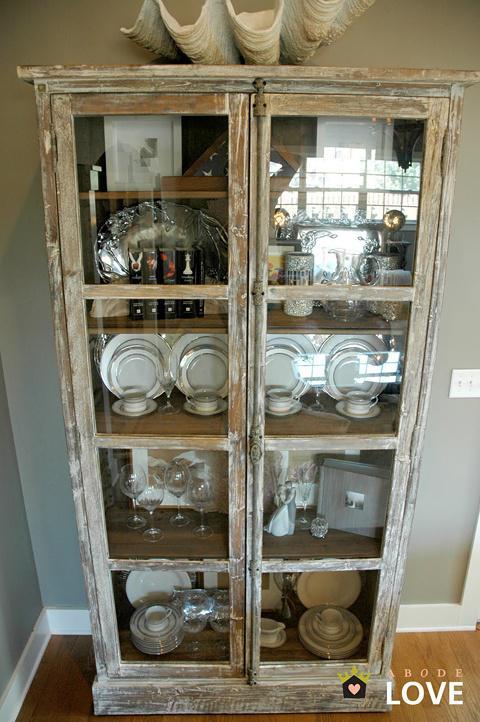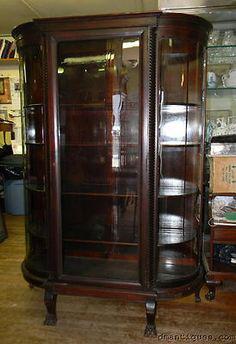The first image is the image on the left, the second image is the image on the right. Examine the images to the left and right. Is the description "There are display items on top of at least one hutch" accurate? Answer yes or no. Yes. 